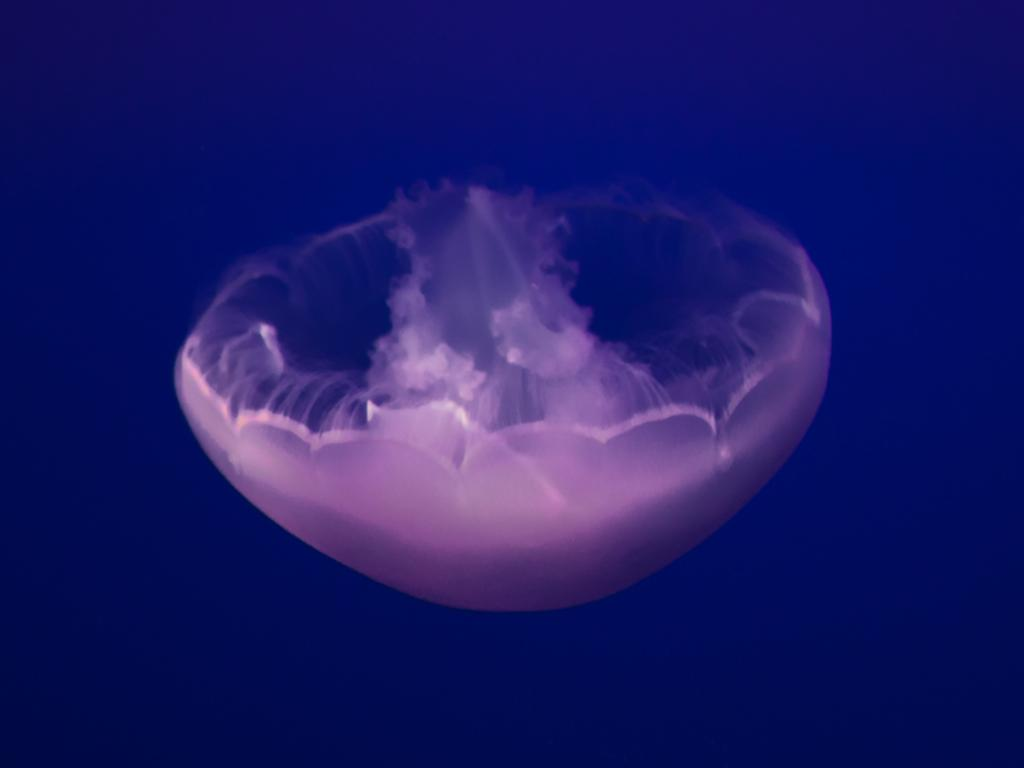What is the main subject in the center of the image? There is a jellyfish in the center of the image. What type of writing can be seen on the desk in the image? There is no desk or writing present in the image; it features a jellyfish in the center. 